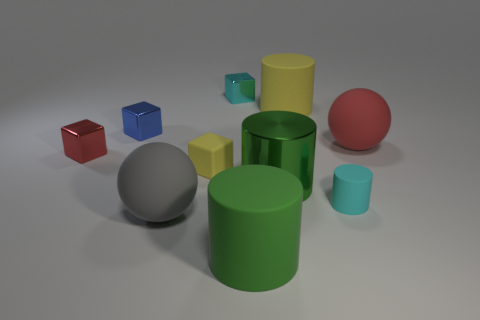Subtract all gray cylinders. Subtract all blue blocks. How many cylinders are left? 4 Subtract all blocks. How many objects are left? 6 Add 1 large yellow matte things. How many large yellow matte things exist? 2 Subtract 0 yellow spheres. How many objects are left? 10 Subtract all cyan metallic spheres. Subtract all cyan rubber cylinders. How many objects are left? 9 Add 6 yellow matte objects. How many yellow matte objects are left? 8 